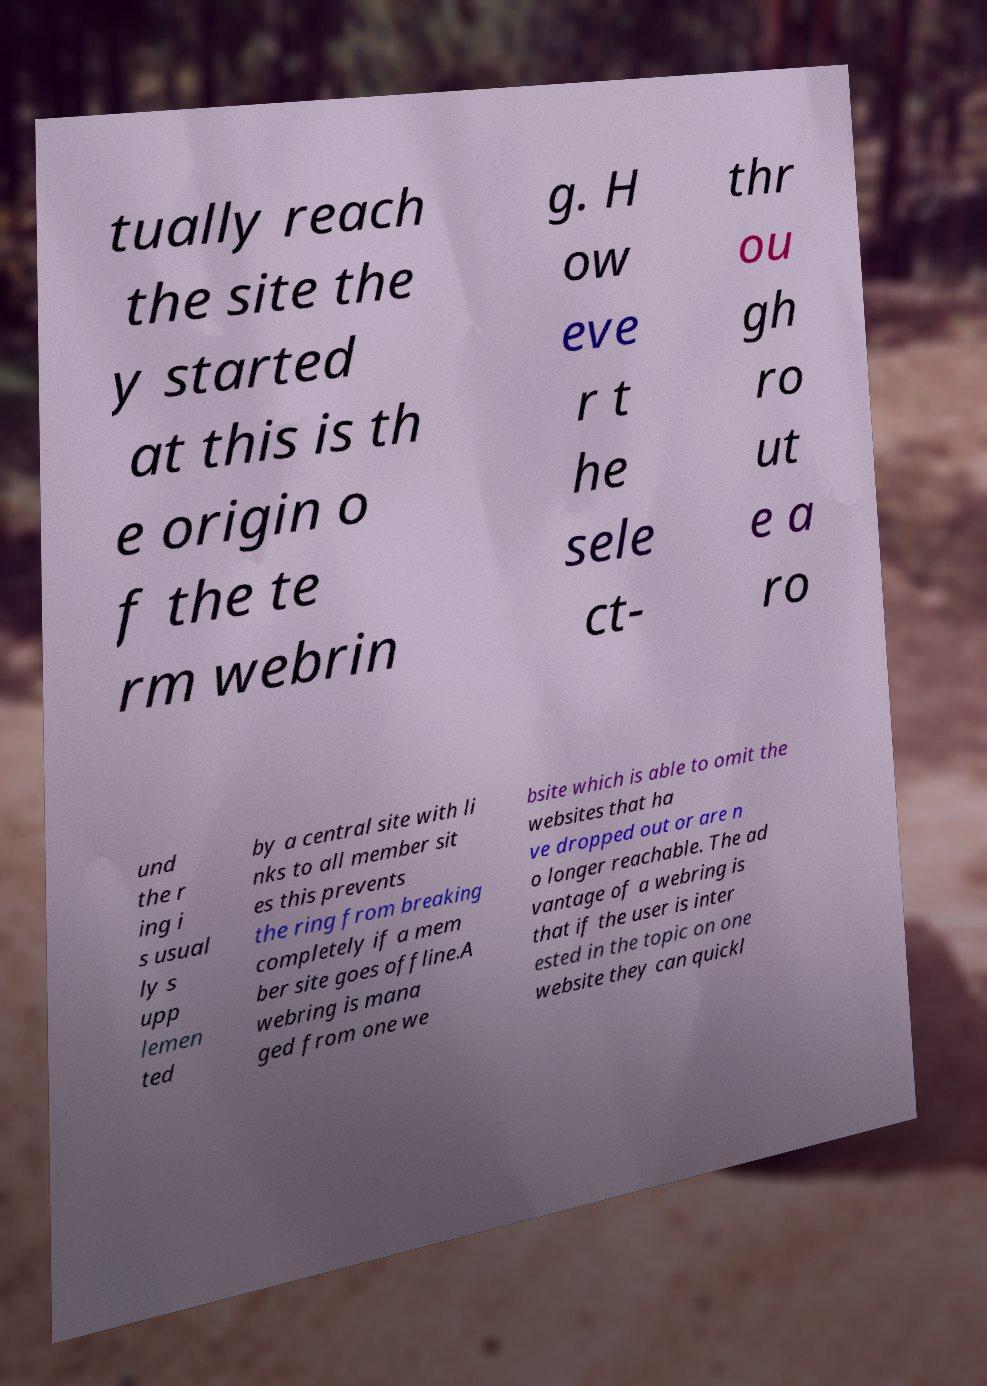Please read and relay the text visible in this image. What does it say? tually reach the site the y started at this is th e origin o f the te rm webrin g. H ow eve r t he sele ct- thr ou gh ro ut e a ro und the r ing i s usual ly s upp lemen ted by a central site with li nks to all member sit es this prevents the ring from breaking completely if a mem ber site goes offline.A webring is mana ged from one we bsite which is able to omit the websites that ha ve dropped out or are n o longer reachable. The ad vantage of a webring is that if the user is inter ested in the topic on one website they can quickl 